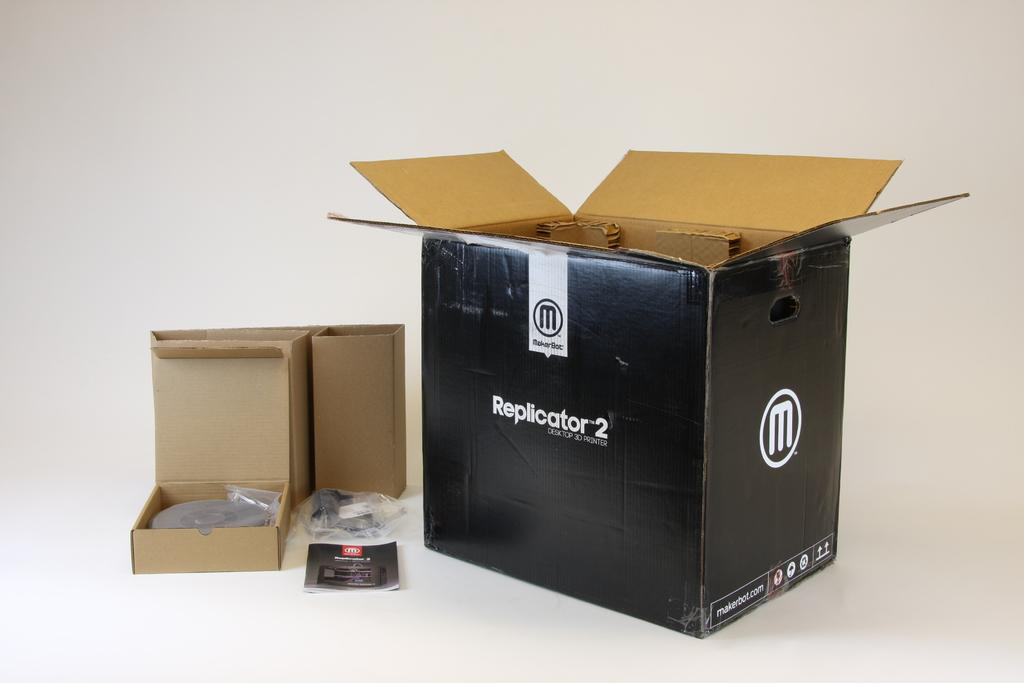<image>
Provide a brief description of the given image. The Replicator 2 box has already been opened. 